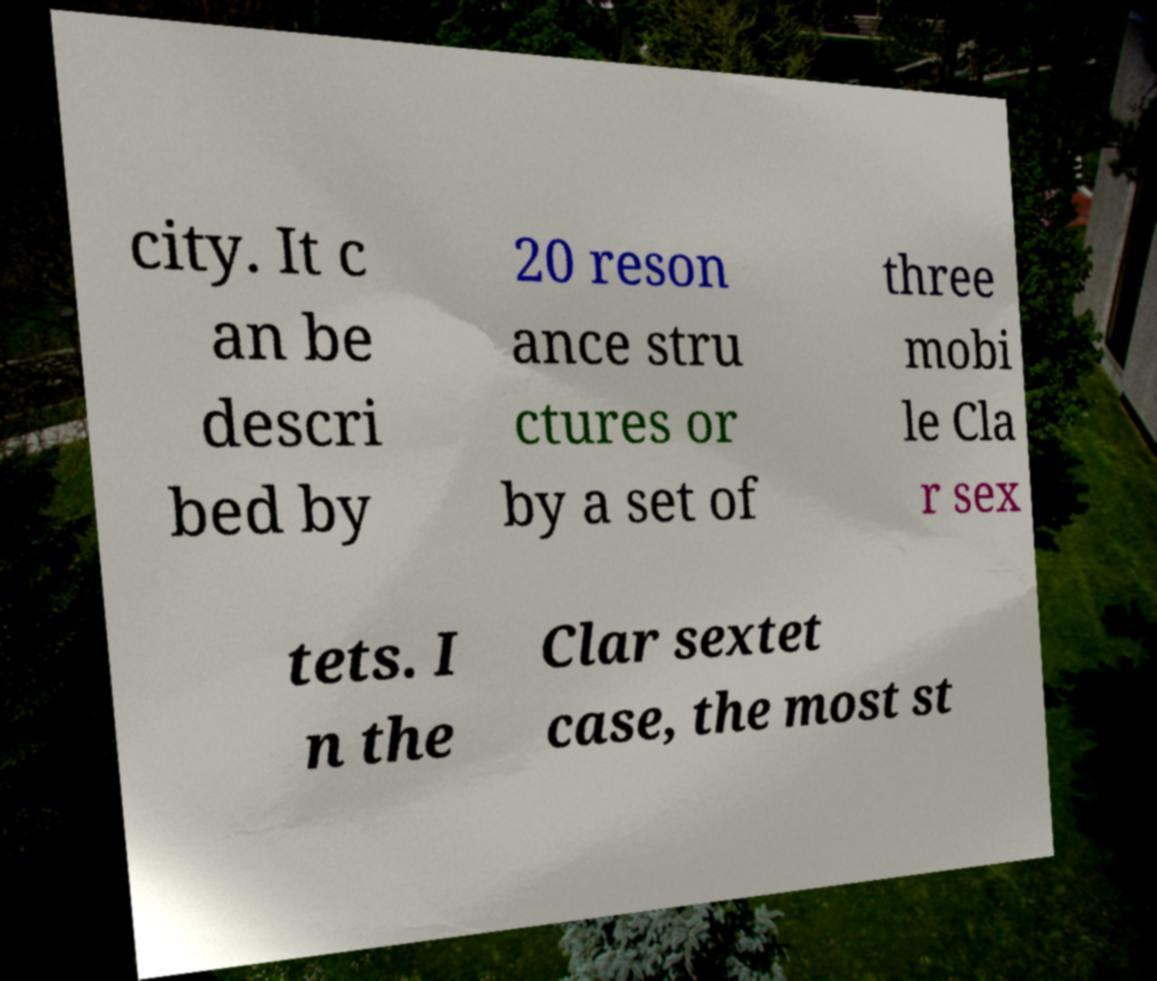For documentation purposes, I need the text within this image transcribed. Could you provide that? city. It c an be descri bed by 20 reson ance stru ctures or by a set of three mobi le Cla r sex tets. I n the Clar sextet case, the most st 